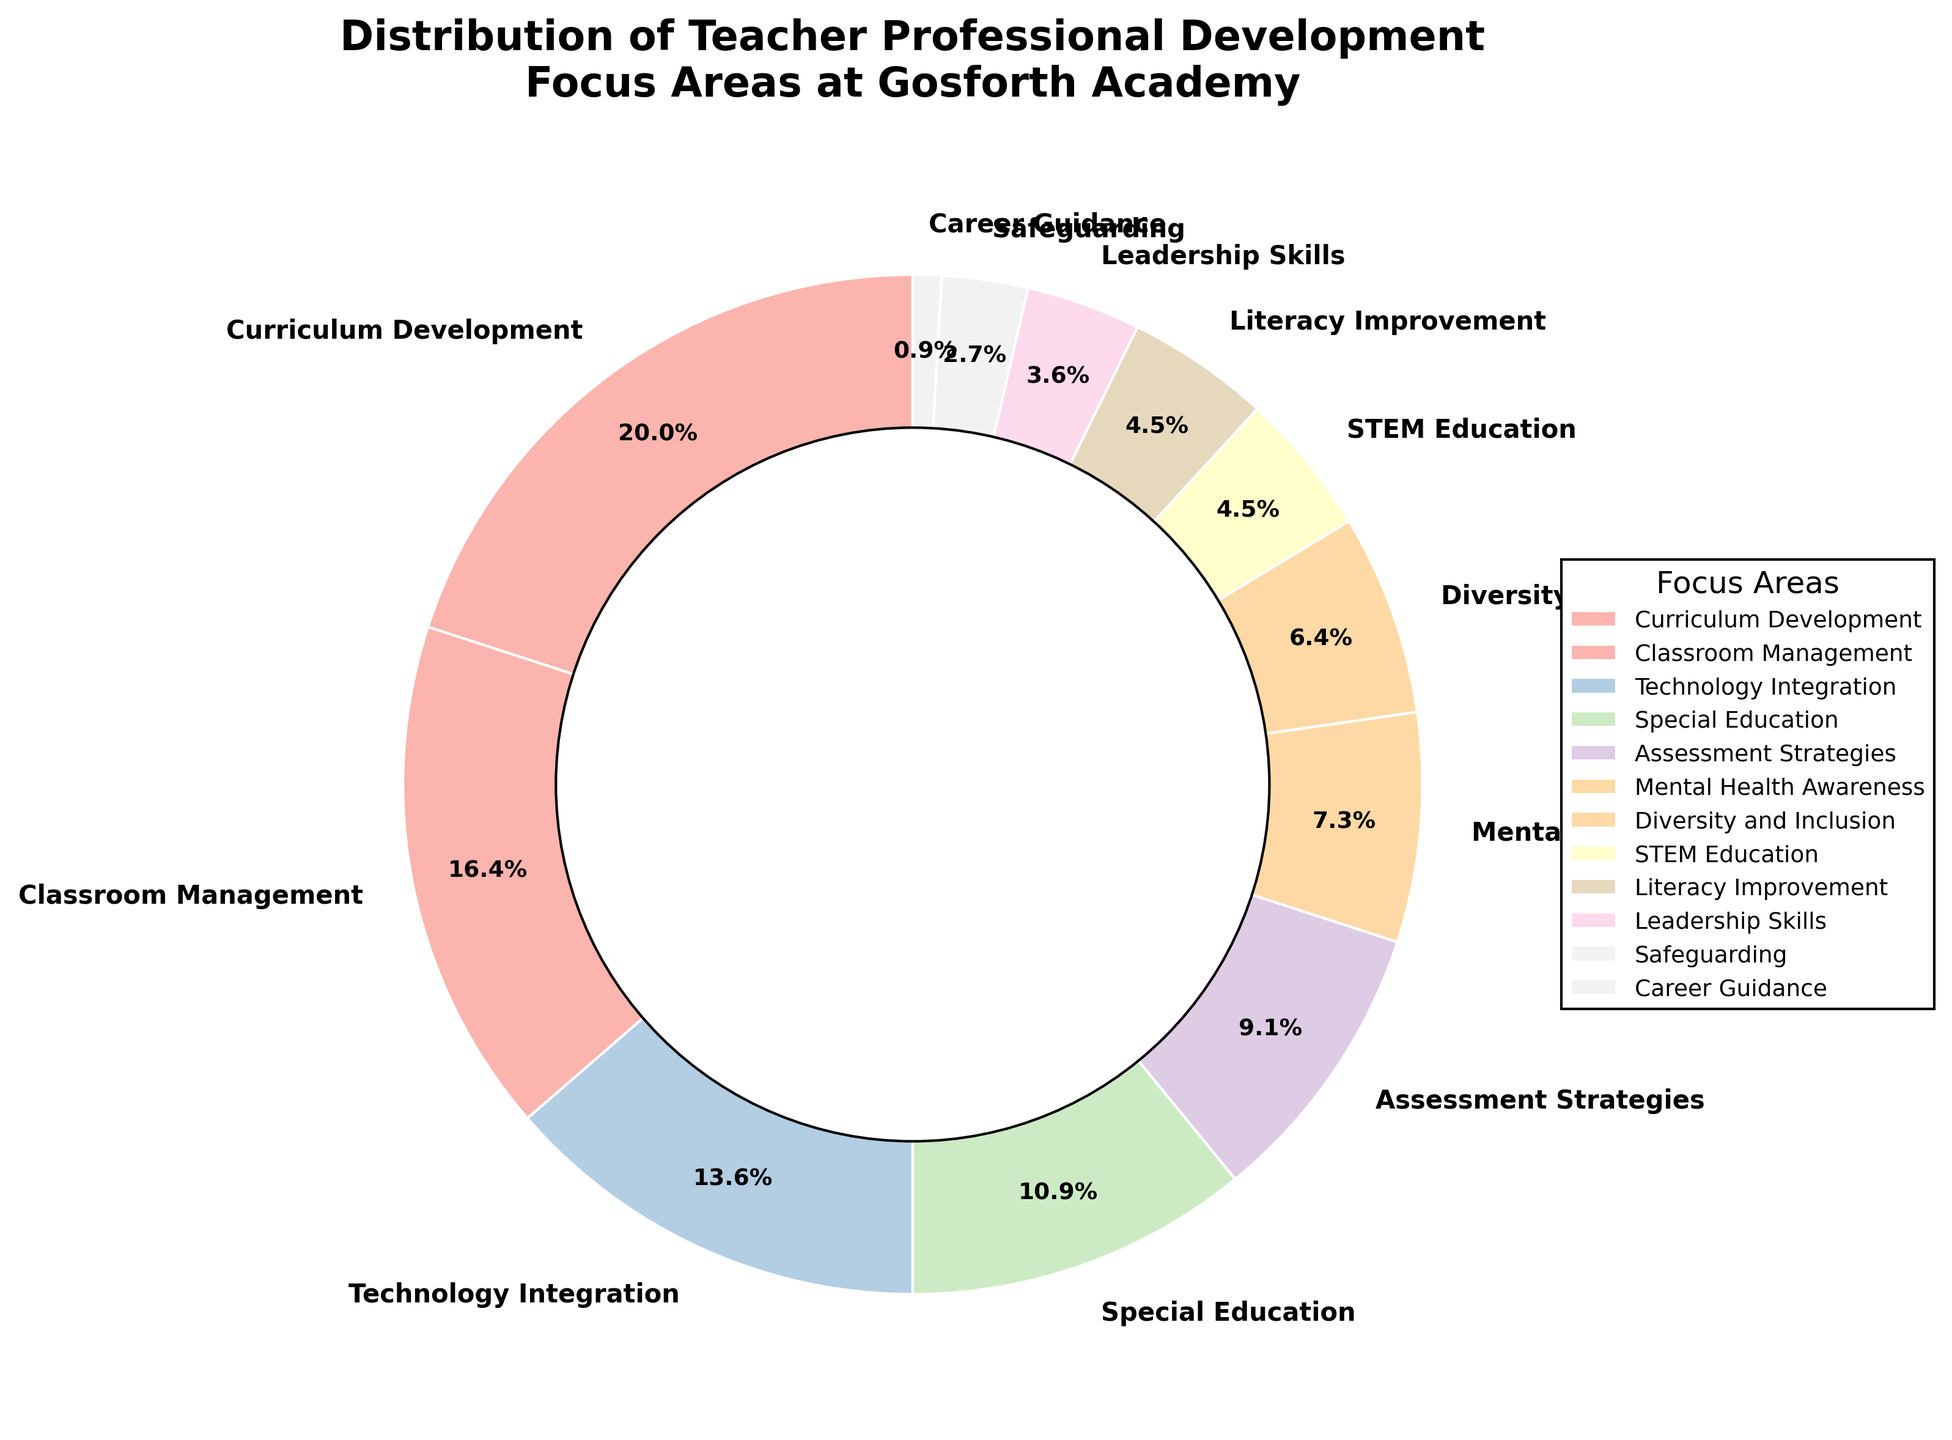What percentage of the teacher professional development focus is on Mental Health Awareness? According to the pie chart, the segment labeled "Mental Health Awareness" represents 8% of the distribution of teacher professional development focus areas at Gosforth Academy.
Answer: 8% Which focus area has the largest percentage allocation? The pie chart shows several focus areas with varying percentages. The largest segment is labeled "Curriculum Development," which occupies 22% of the distribution.
Answer: Curriculum Development What is the combined percentage for Special Education and Assessment Strategies? According to the pie chart, Special Education accounts for 12% and Assessment Strategies accounts for 10%. Adding these two percentages together, 12% + 10% = 22%.
Answer: 22% Which focus area is allocated the least percentage? Examining the pie chart, the smallest segment is labeled "Career Guidance," which occupies 1% of the distribution.
Answer: Career Guidance How does the allocation for Technology Integration compare to that for Classroom Management? The pie chart shows that Technology Integration is allocated 15%, while Classroom Management is allocated 18%. Since 15% is less than 18%, Technology Integration has a smaller allocation compared to Classroom Management.
Answer: Technology Integration is less than Classroom Management What is the total percentage for focus areas related to classroom tactics (Classroom Management and Assessment Strategies)? According to the pie chart, Classroom Management is 18% and Assessment Strategies is 10%. Summing these values, 18% + 10% = 28%.
Answer: 28% Out of Literacy Improvement, STEM Education, and Leadership Skills, which area has the highest focus? The pie chart shows that Literacy Improvement and STEM Education both have 5%, while Leadership Skills has 4%. Since 5% is greater than 4%, the highest focus among these three areas is shared by Literacy Improvement and STEM Education.
Answer: Literacy Improvement and STEM Education How do the allocations for Diversity and Inclusion and Safeguarding compare? From the pie chart, Diversity and Inclusion is assigned 7%, while Safeguarding is assigned 3%. Since 7% is greater than 3%, Diversity and Inclusion has a higher allocation compared to Safeguarding.
Answer: Diversity and Inclusion is greater than Safeguarding 